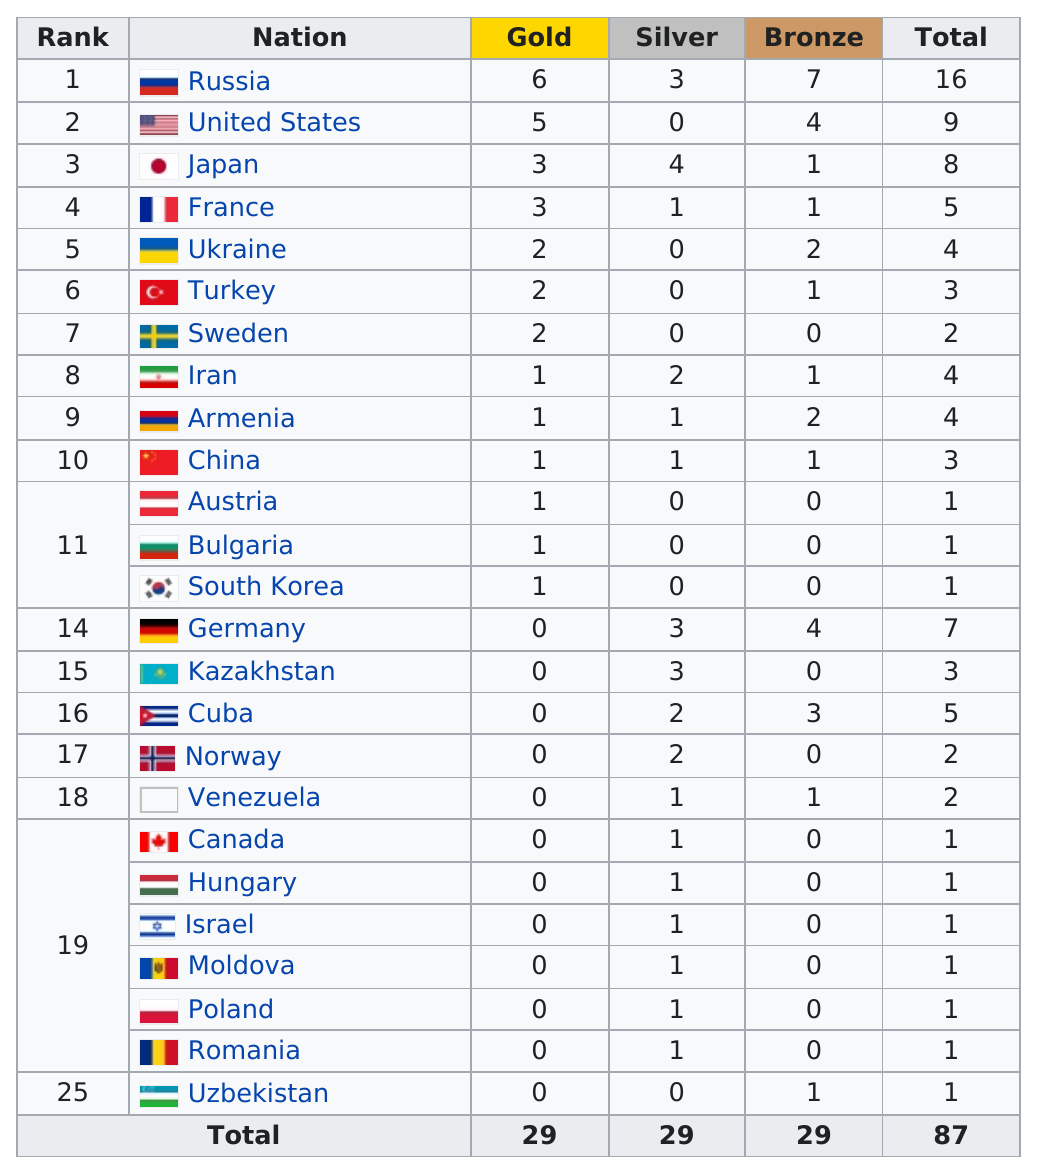Highlight a few significant elements in this photo. Turkey did not win any silver medals. Russia won the most medals in the country with the highest number of medals. It is Russia that ranked first, and not the United States. Japan and France each won three gold medals. Japan and France won a combined total of six gold medals. 